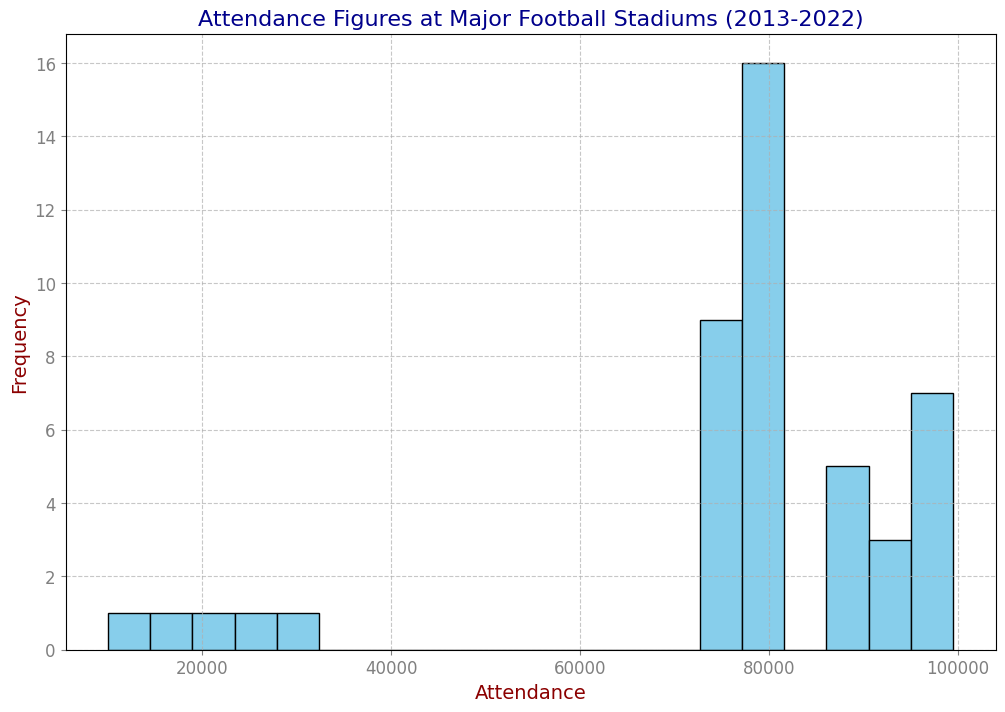What is the most frequent attendance range? By looking at the bars in the histogram, we see the highest bar represents the range containing the most attendance records. Identify the attendance range on the x-axis corresponding to this tallest bar.
Answer: 90000-91000 How many distinct attendance ranges are represented in the histogram? Count the number of bars on the histogram. Each bar represents a distinct attendance range.
Answer: 20 Which attendance range has the lowest frequency? Look for the shortest bar in the histogram. Identify the attendance range on the x-axis corresponding to this shortest bar.
Answer: 70000-71000 Is the attendance range from 80000 to 81000 more frequent than from 90000 to 91000? Compare the heights of the bars that fall within the ranges of 80000-81000 and 90000-91000. The bar with a higher value represents a more frequent range.
Answer: No What is the range of attendance values displayed in the histogram? Identify the lowest and highest attendance values on the x-axis. Subtract the lowest value from the highest to get the range.
Answer: 70000-100000 What is the sum of frequencies for the attendance ranges 80000-81000, 81000-82000, and 82000-83000? Add the heights of the bars corresponding to the attendance ranges 80000-81000, 81000-82000, and 82000-83000.
Answer: 21 Which attendance range shows a notable spike, indicating a potential outlier? Observe if any bar significantly deviates in height compared to the others. Identify the attendance range on the x-axis corresponding to this bar.
Answer: 90000-91000 Is there a noticeable drop in frequencies for a specific attendance range, and what might it indicate? Look for a sudden decrease in bar height among the histogram bars, which may indicate an anomaly or special event. Identify the range on the x-axis.
Answer: 70000-71000 Is the frequency of attendance in the range 90000-91000 greater or less than the frequency in the range 81000-82000? Compare the heights of the bars for the ranges 90000-91000 and 81000-82000. The taller bar indicates a greater frequency.
Answer: Greater How many bars represent attendance figures below 80000? Count the number of bars on the left side of the 80000 mark on the x-axis. Each of these bars represents a range below 80000.
Answer: 1 